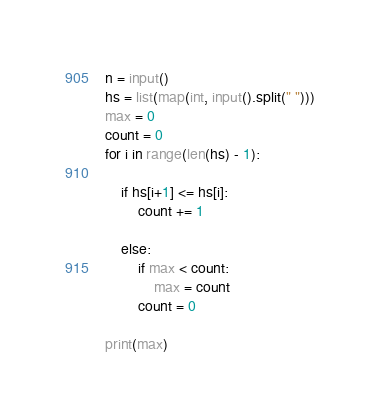Convert code to text. <code><loc_0><loc_0><loc_500><loc_500><_Python_>n = input()
hs = list(map(int, input().split(" ")))
max = 0
count = 0
for i in range(len(hs) - 1):

    if hs[i+1] <= hs[i]:
        count += 1

    else:
        if max < count:
            max = count
        count = 0

print(max)</code> 